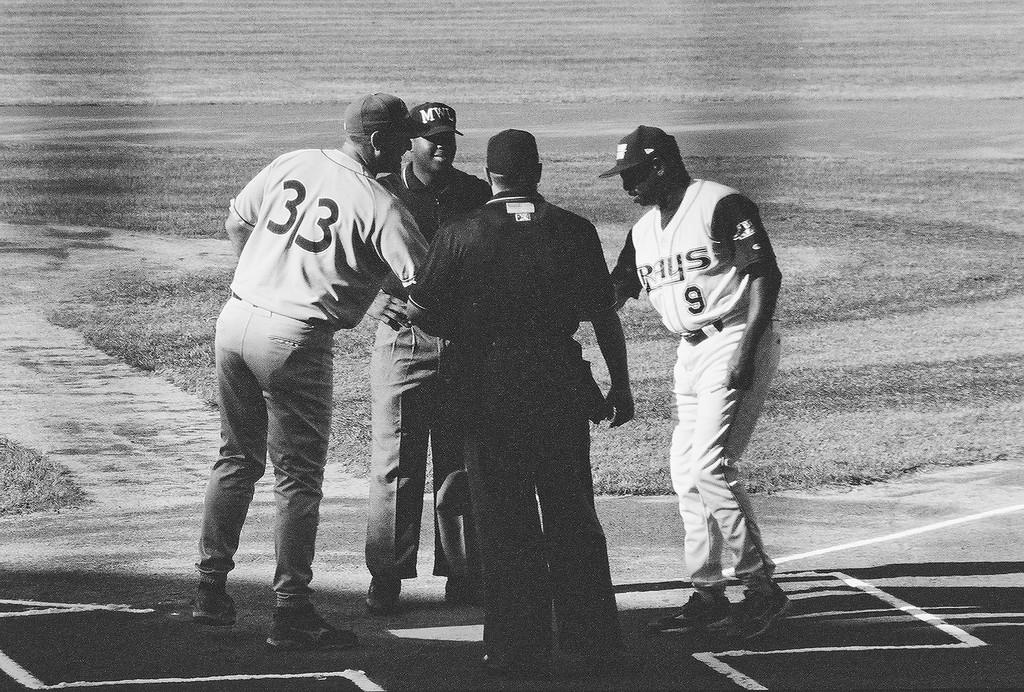Provide a one-sentence caption for the provided image. A man in a number 33 jersey shakes hands over home plate with a Rays player. 